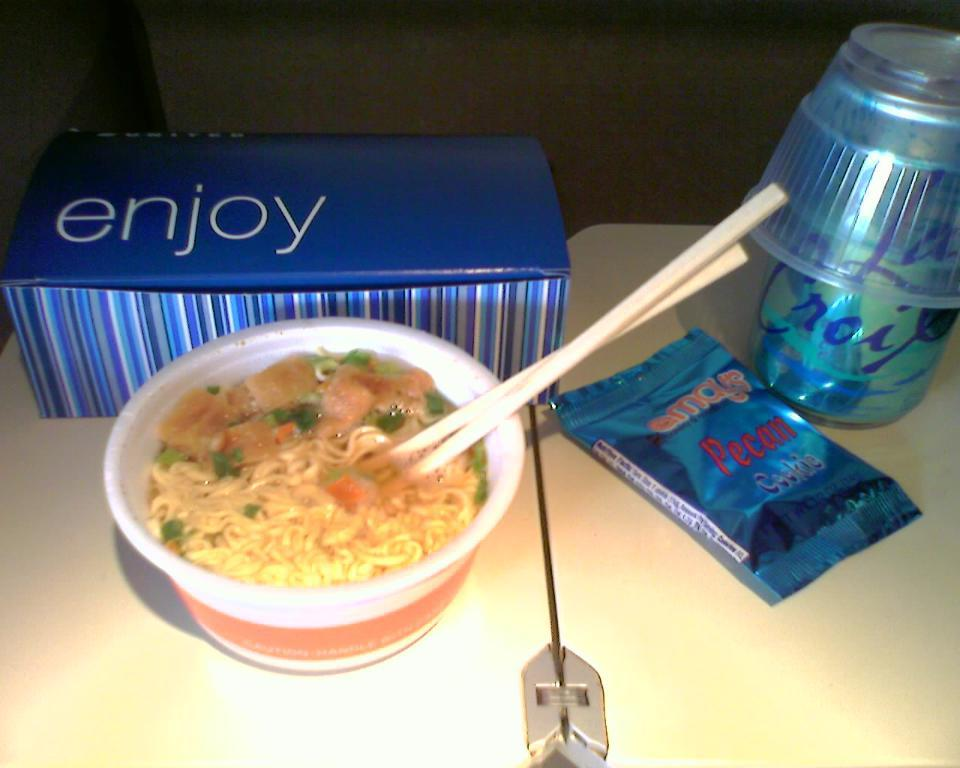<image>
Share a concise interpretation of the image provided. cup of noodle soup and pecan desert on the table 